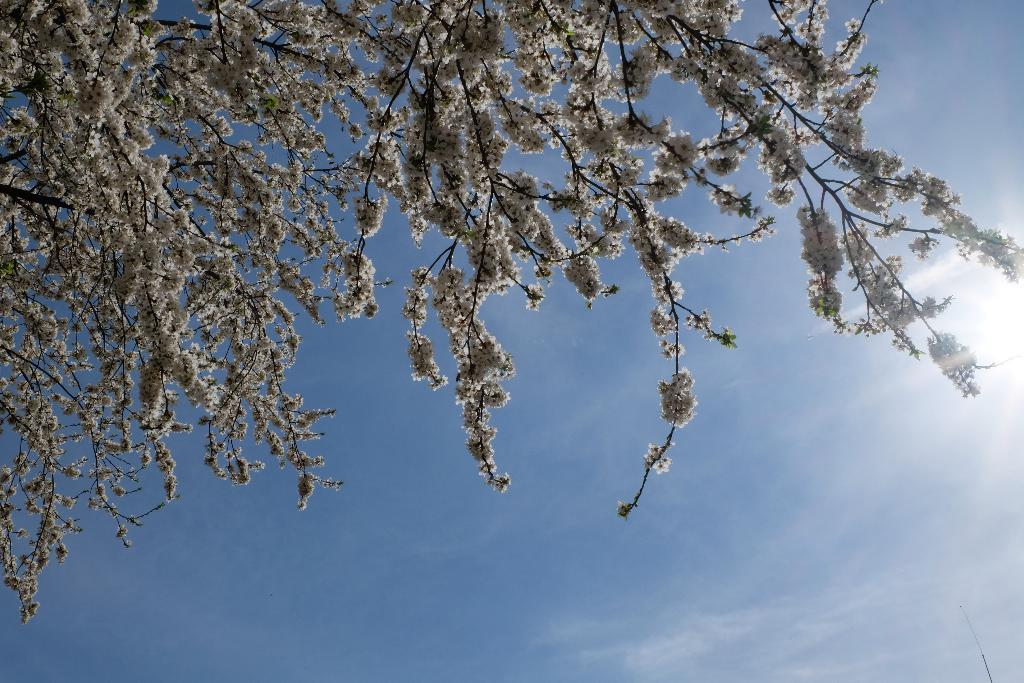What type of flowers can be seen in the image? There are white color flowers in the image. What is the color of the sky in the image? The sky is blue and white in color. Where is the clock located in the image? There is no clock present in the image. What type of crate can be seen in the image? There is no crate present in the image. 